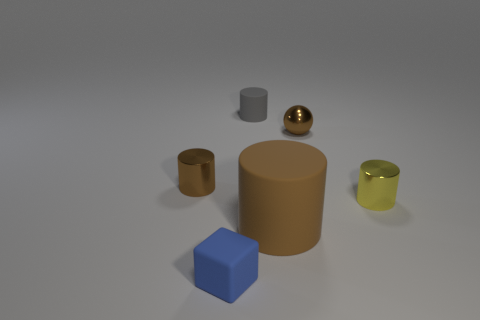Subtract all brown cubes. How many brown cylinders are left? 2 Subtract all small cylinders. How many cylinders are left? 1 Subtract all yellow cylinders. How many cylinders are left? 3 Add 1 small metal spheres. How many objects exist? 7 Subtract all purple cylinders. Subtract all purple cubes. How many cylinders are left? 4 Subtract all cubes. How many objects are left? 5 Subtract 0 red blocks. How many objects are left? 6 Subtract all yellow cylinders. Subtract all yellow shiny things. How many objects are left? 4 Add 1 blue blocks. How many blue blocks are left? 2 Add 1 small cyan objects. How many small cyan objects exist? 1 